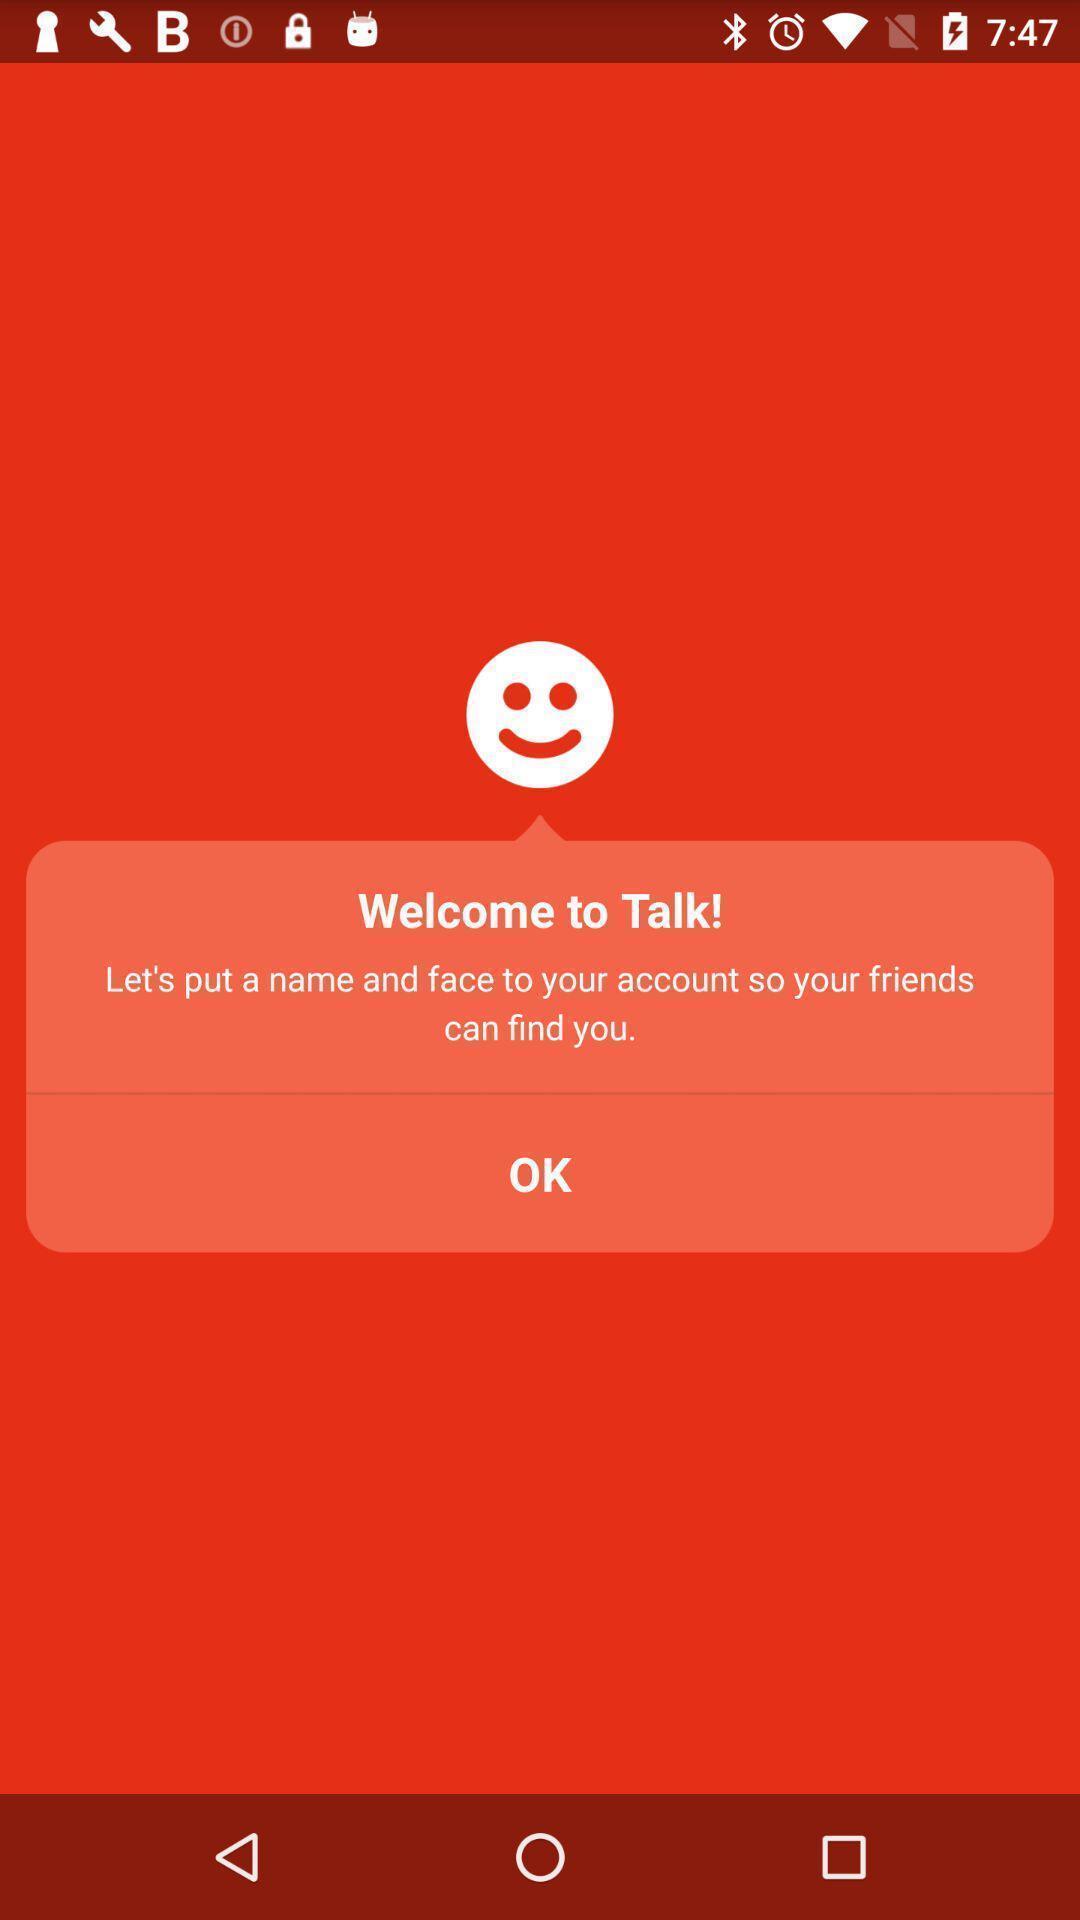Describe the visual elements of this screenshot. Welcome page to put a name to your account. 